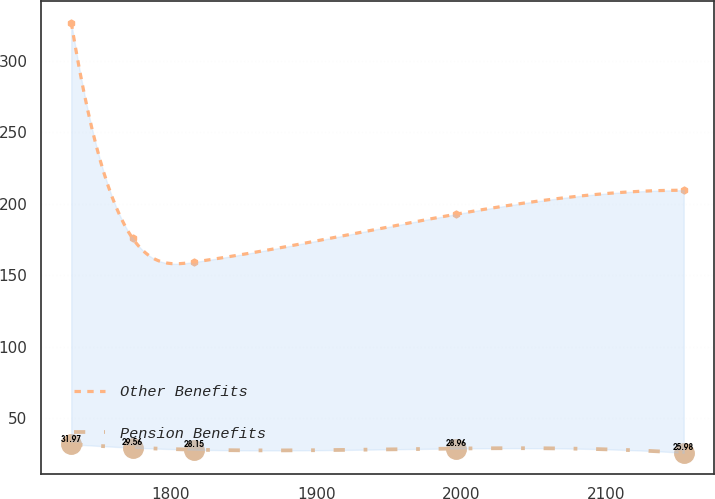<chart> <loc_0><loc_0><loc_500><loc_500><line_chart><ecel><fcel>Other Benefits<fcel>Pension Benefits<nl><fcel>1731.28<fcel>326.74<fcel>31.97<nl><fcel>1773.48<fcel>176.03<fcel>29.56<nl><fcel>1815.68<fcel>159.29<fcel>28.15<nl><fcel>1996.42<fcel>192.78<fcel>28.96<nl><fcel>2153.24<fcel>209.53<fcel>25.98<nl></chart> 